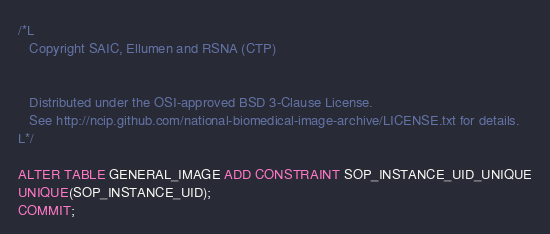Convert code to text. <code><loc_0><loc_0><loc_500><loc_500><_SQL_>/*L
   Copyright SAIC, Ellumen and RSNA (CTP)


   Distributed under the OSI-approved BSD 3-Clause License.
   See http://ncip.github.com/national-biomedical-image-archive/LICENSE.txt for details.
L*/

ALTER TABLE GENERAL_IMAGE ADD CONSTRAINT SOP_INSTANCE_UID_UNIQUE
UNIQUE(SOP_INSTANCE_UID);
COMMIT;</code> 